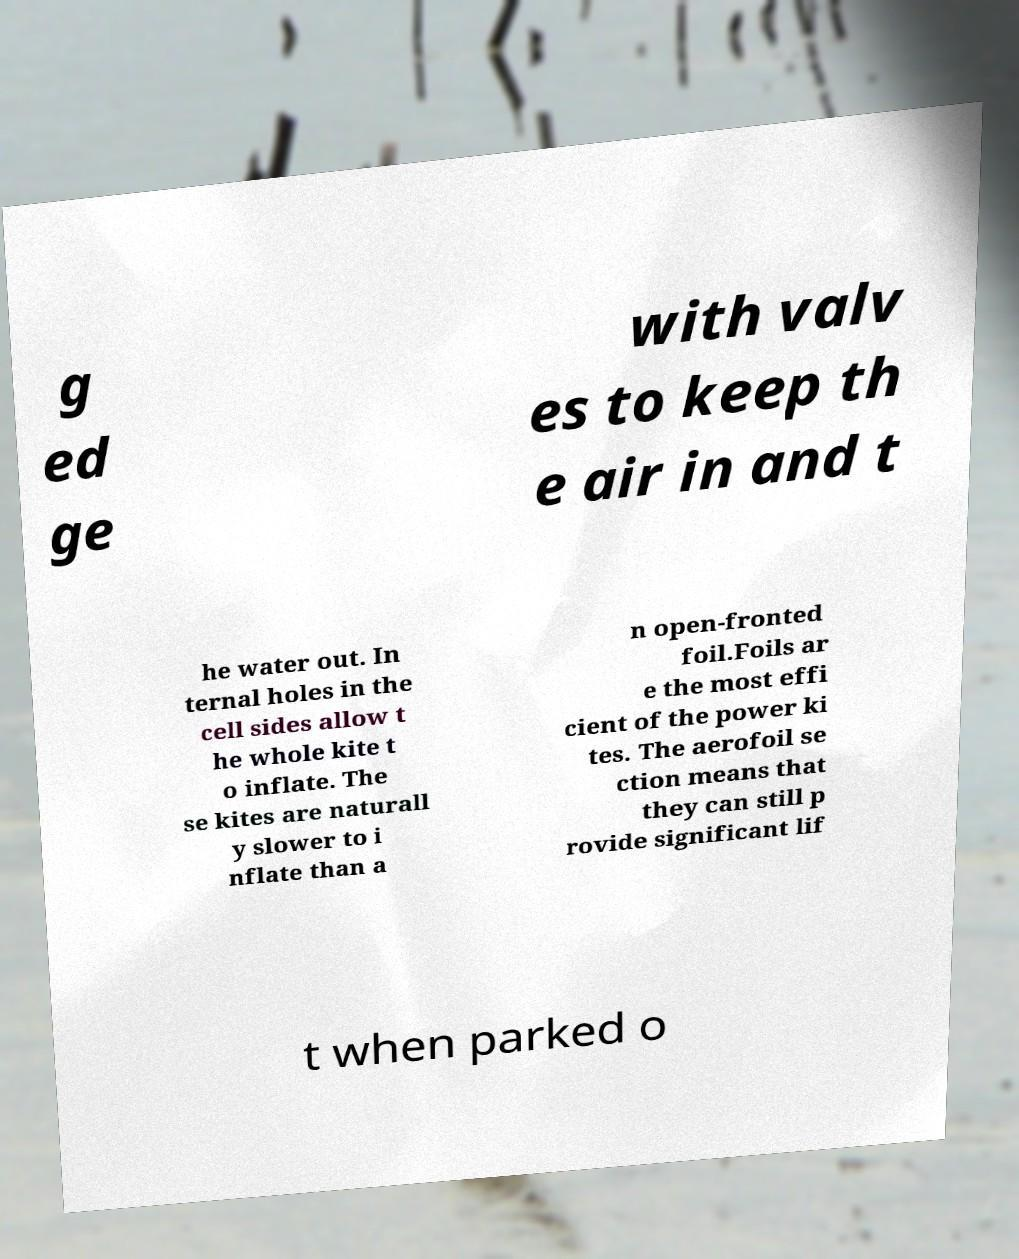What messages or text are displayed in this image? I need them in a readable, typed format. g ed ge with valv es to keep th e air in and t he water out. In ternal holes in the cell sides allow t he whole kite t o inflate. The se kites are naturall y slower to i nflate than a n open-fronted foil.Foils ar e the most effi cient of the power ki tes. The aerofoil se ction means that they can still p rovide significant lif t when parked o 